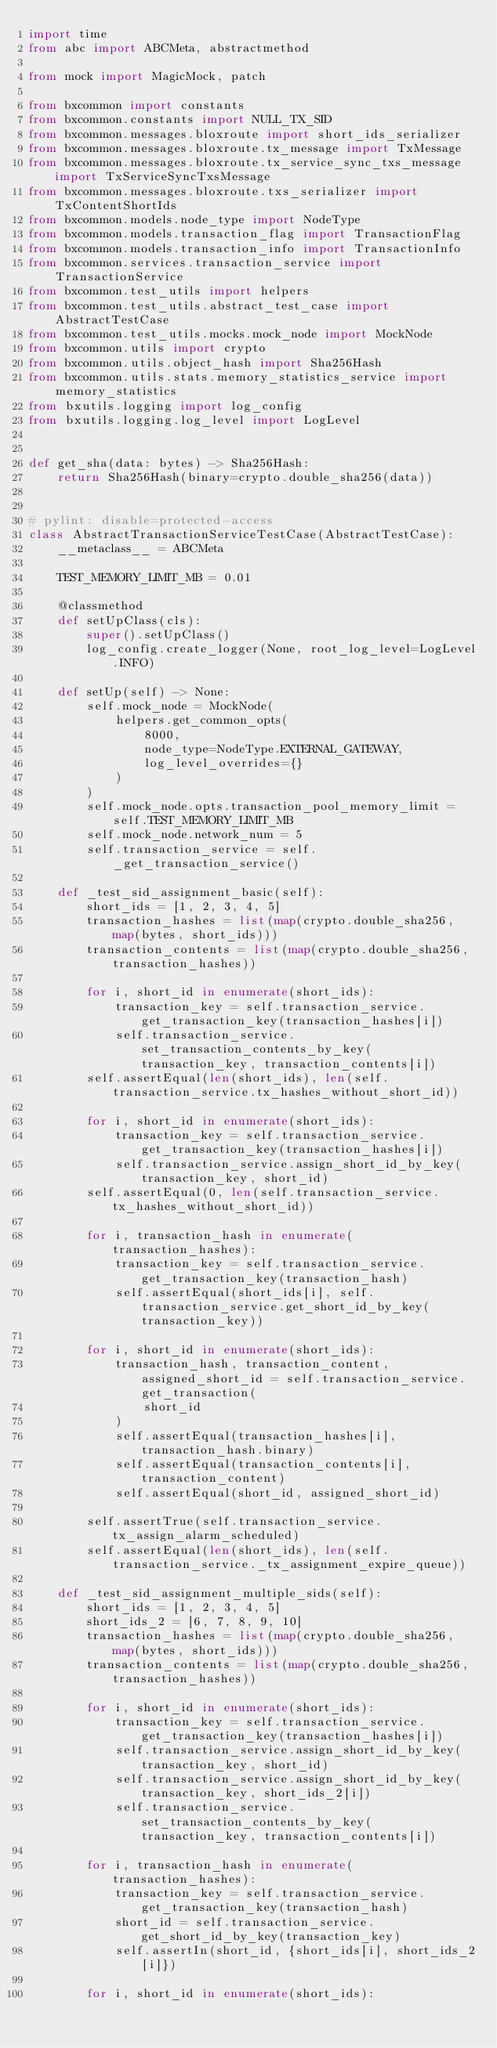<code> <loc_0><loc_0><loc_500><loc_500><_Python_>import time
from abc import ABCMeta, abstractmethod

from mock import MagicMock, patch

from bxcommon import constants
from bxcommon.constants import NULL_TX_SID
from bxcommon.messages.bloxroute import short_ids_serializer
from bxcommon.messages.bloxroute.tx_message import TxMessage
from bxcommon.messages.bloxroute.tx_service_sync_txs_message import TxServiceSyncTxsMessage
from bxcommon.messages.bloxroute.txs_serializer import TxContentShortIds
from bxcommon.models.node_type import NodeType
from bxcommon.models.transaction_flag import TransactionFlag
from bxcommon.models.transaction_info import TransactionInfo
from bxcommon.services.transaction_service import TransactionService
from bxcommon.test_utils import helpers
from bxcommon.test_utils.abstract_test_case import AbstractTestCase
from bxcommon.test_utils.mocks.mock_node import MockNode
from bxcommon.utils import crypto
from bxcommon.utils.object_hash import Sha256Hash
from bxcommon.utils.stats.memory_statistics_service import memory_statistics
from bxutils.logging import log_config
from bxutils.logging.log_level import LogLevel


def get_sha(data: bytes) -> Sha256Hash:
    return Sha256Hash(binary=crypto.double_sha256(data))


# pylint: disable=protected-access
class AbstractTransactionServiceTestCase(AbstractTestCase):
    __metaclass__ = ABCMeta

    TEST_MEMORY_LIMIT_MB = 0.01

    @classmethod
    def setUpClass(cls):
        super().setUpClass()
        log_config.create_logger(None, root_log_level=LogLevel.INFO)

    def setUp(self) -> None:
        self.mock_node = MockNode(
            helpers.get_common_opts(
                8000,
                node_type=NodeType.EXTERNAL_GATEWAY,
                log_level_overrides={}
            )
        )
        self.mock_node.opts.transaction_pool_memory_limit = self.TEST_MEMORY_LIMIT_MB
        self.mock_node.network_num = 5
        self.transaction_service = self._get_transaction_service()

    def _test_sid_assignment_basic(self):
        short_ids = [1, 2, 3, 4, 5]
        transaction_hashes = list(map(crypto.double_sha256, map(bytes, short_ids)))
        transaction_contents = list(map(crypto.double_sha256, transaction_hashes))

        for i, short_id in enumerate(short_ids):
            transaction_key = self.transaction_service.get_transaction_key(transaction_hashes[i])
            self.transaction_service.set_transaction_contents_by_key(transaction_key, transaction_contents[i])
        self.assertEqual(len(short_ids), len(self.transaction_service.tx_hashes_without_short_id))

        for i, short_id in enumerate(short_ids):
            transaction_key = self.transaction_service.get_transaction_key(transaction_hashes[i])
            self.transaction_service.assign_short_id_by_key(transaction_key, short_id)
        self.assertEqual(0, len(self.transaction_service.tx_hashes_without_short_id))

        for i, transaction_hash in enumerate(transaction_hashes):
            transaction_key = self.transaction_service.get_transaction_key(transaction_hash)
            self.assertEqual(short_ids[i], self.transaction_service.get_short_id_by_key(transaction_key))

        for i, short_id in enumerate(short_ids):
            transaction_hash, transaction_content, assigned_short_id = self.transaction_service.get_transaction(
                short_id
            )
            self.assertEqual(transaction_hashes[i], transaction_hash.binary)
            self.assertEqual(transaction_contents[i], transaction_content)
            self.assertEqual(short_id, assigned_short_id)

        self.assertTrue(self.transaction_service.tx_assign_alarm_scheduled)
        self.assertEqual(len(short_ids), len(self.transaction_service._tx_assignment_expire_queue))

    def _test_sid_assignment_multiple_sids(self):
        short_ids = [1, 2, 3, 4, 5]
        short_ids_2 = [6, 7, 8, 9, 10]
        transaction_hashes = list(map(crypto.double_sha256, map(bytes, short_ids)))
        transaction_contents = list(map(crypto.double_sha256, transaction_hashes))

        for i, short_id in enumerate(short_ids):
            transaction_key = self.transaction_service.get_transaction_key(transaction_hashes[i])
            self.transaction_service.assign_short_id_by_key(transaction_key, short_id)
            self.transaction_service.assign_short_id_by_key(transaction_key, short_ids_2[i])
            self.transaction_service.set_transaction_contents_by_key(transaction_key, transaction_contents[i])

        for i, transaction_hash in enumerate(transaction_hashes):
            transaction_key = self.transaction_service.get_transaction_key(transaction_hash)
            short_id = self.transaction_service.get_short_id_by_key(transaction_key)
            self.assertIn(short_id, {short_ids[i], short_ids_2[i]})

        for i, short_id in enumerate(short_ids):</code> 